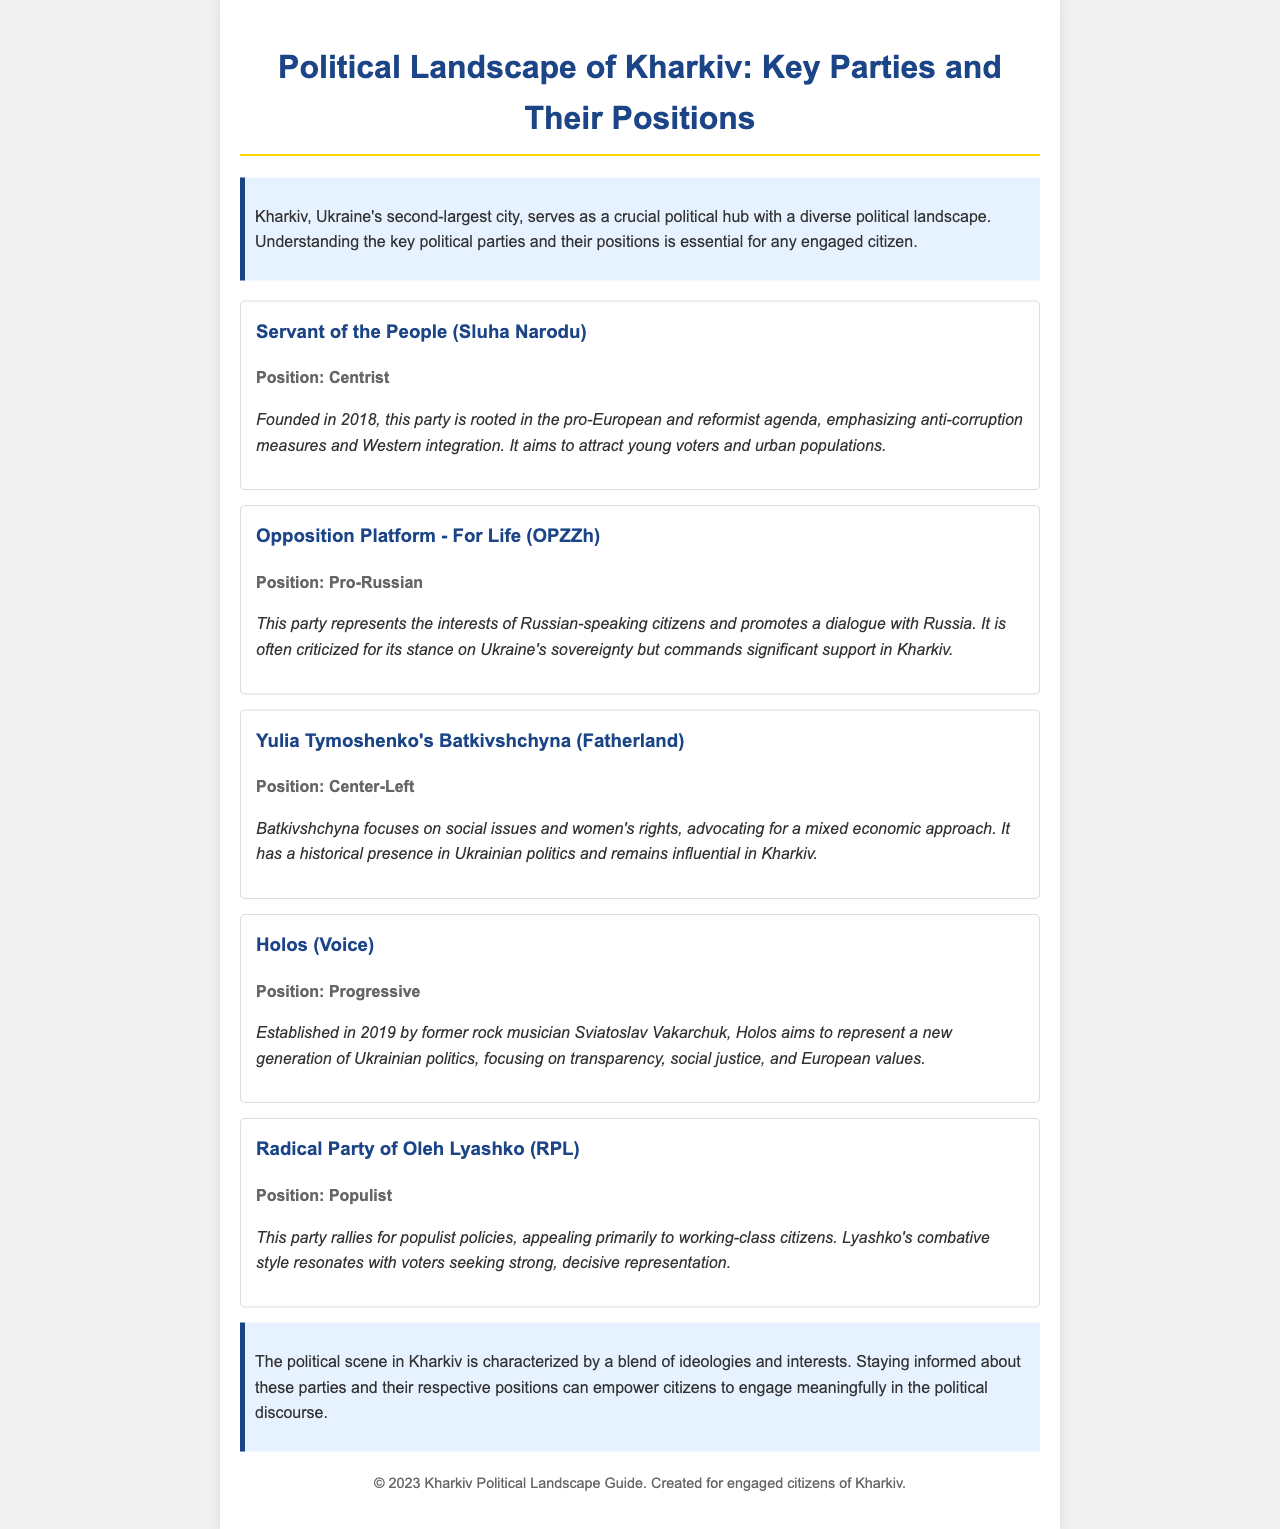What is the title of the document? The title is the main heading that reflects the content of the document, which is presented at the top.
Answer: Political Landscape of Kharkiv: Key Parties and Their Positions Which party is described as centrist? The party's position is stated in the overview section, highlighting its ideological stance.
Answer: Servant of the People (Sluha Narodu) When was the Servant of the People party founded? The founding year is mentioned in the overview of the party, providing important historical context.
Answer: 2018 What is the position of the Opposition Platform - For Life? The position gives insight into the party's political alignment, crucial for understanding its stance.
Answer: Pro-Russian Who founded the Holos party? The founder's name is significant for understanding the party's origins and its representation.
Answer: Sviatoslav Vakarchuk What does the Radical Party of Oleh Lyashko primarily appeal to? This appeal indicates the demographic the party targets, which is critical for analyzing voter base.
Answer: Working-class citizens What color is used for the section titles in the document? The color can give a visual representation of the document's style and help in identifying sections.
Answer: #1c4587 What is one major focus of Yulia Tymoshenko's Batkivshchyna? Identifying this focus helps understand the party's priorities and policies advocated in Kharkiv.
Answer: Social issues 